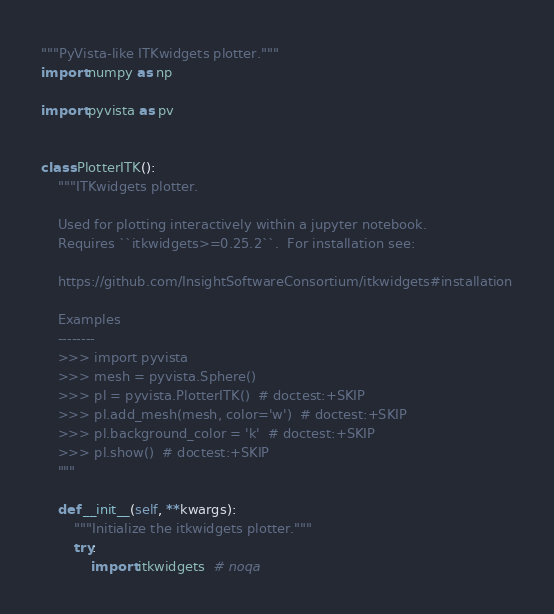Convert code to text. <code><loc_0><loc_0><loc_500><loc_500><_Python_>"""PyVista-like ITKwidgets plotter."""
import numpy as np

import pyvista as pv


class PlotterITK():
    """ITKwidgets plotter.

    Used for plotting interactively within a jupyter notebook.
    Requires ``itkwidgets>=0.25.2``.  For installation see:

    https://github.com/InsightSoftwareConsortium/itkwidgets#installation

    Examples
    --------
    >>> import pyvista
    >>> mesh = pyvista.Sphere()
    >>> pl = pyvista.PlotterITK()  # doctest:+SKIP
    >>> pl.add_mesh(mesh, color='w')  # doctest:+SKIP
    >>> pl.background_color = 'k'  # doctest:+SKIP
    >>> pl.show()  # doctest:+SKIP
    """

    def __init__(self, **kwargs):
        """Initialize the itkwidgets plotter."""
        try:
            import itkwidgets  # noqa</code> 